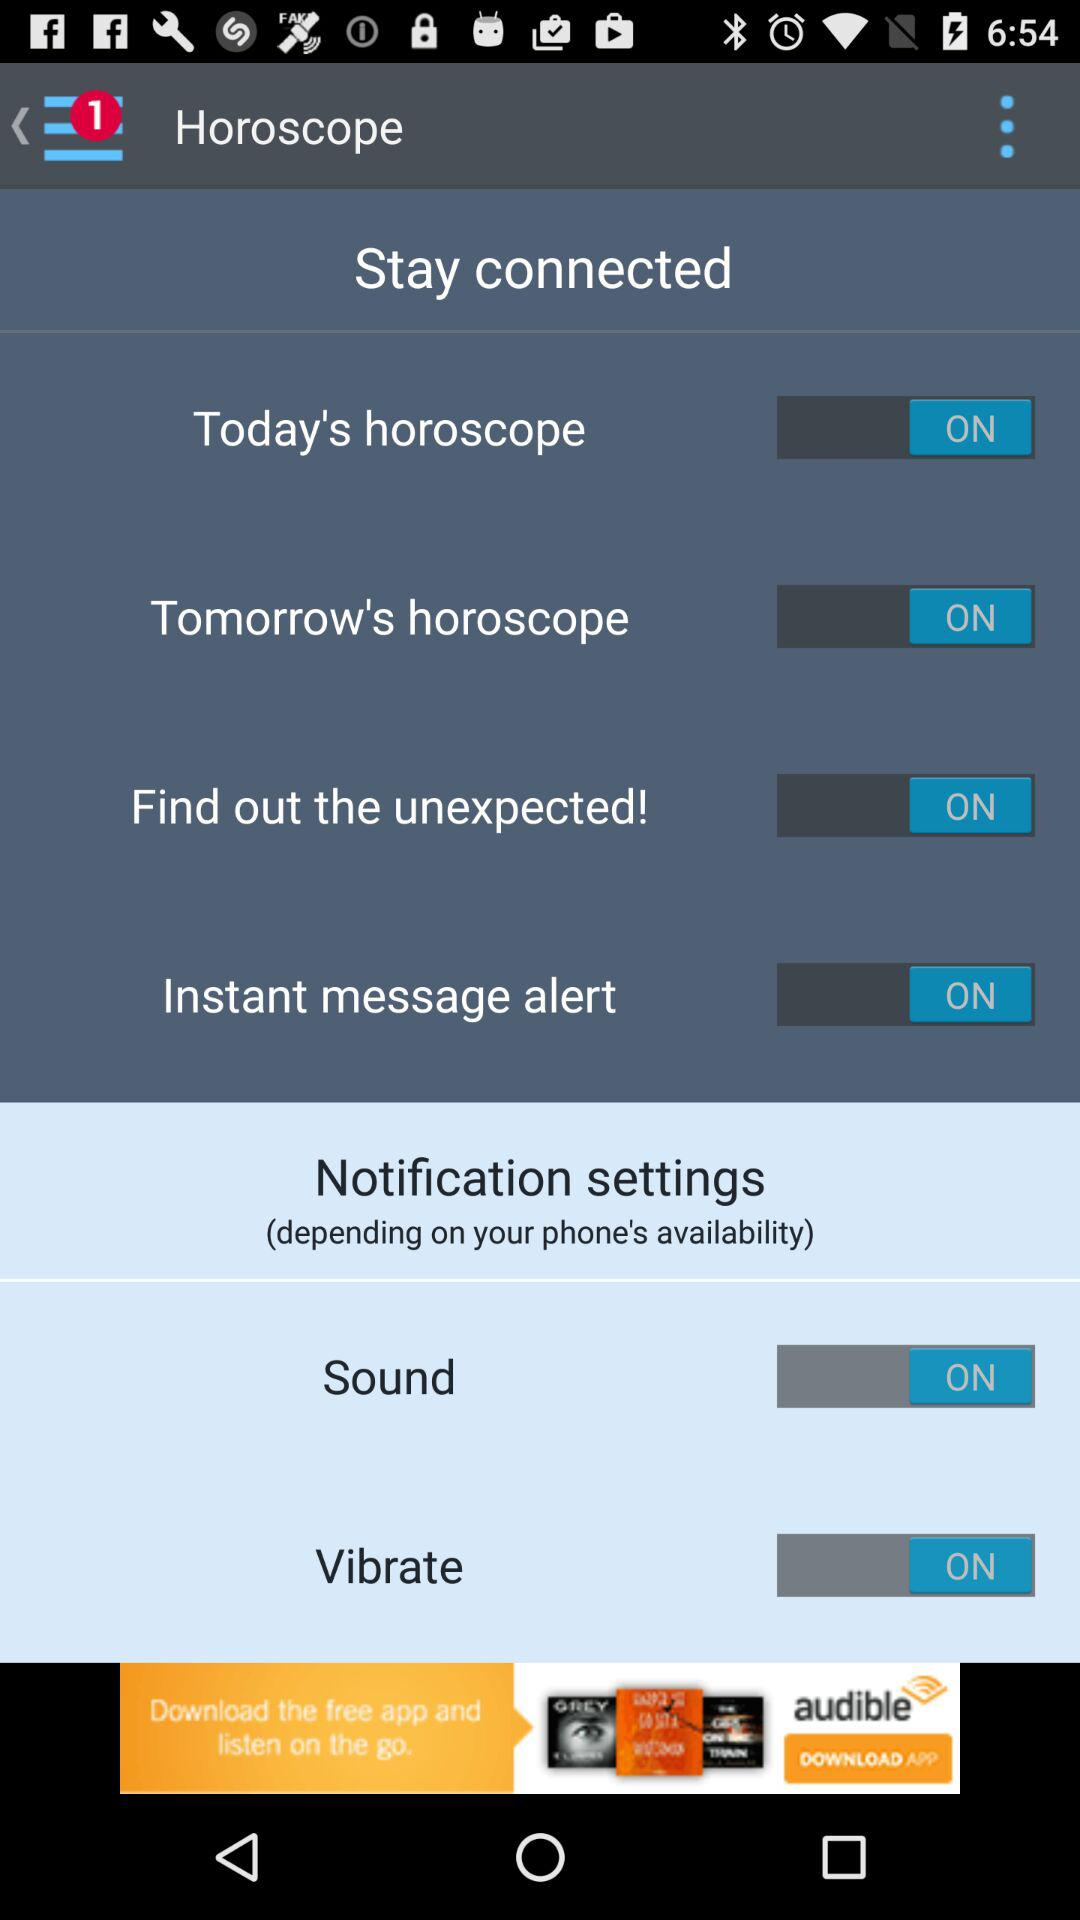How many notifications are shown on the screen? There is 1 notification. 